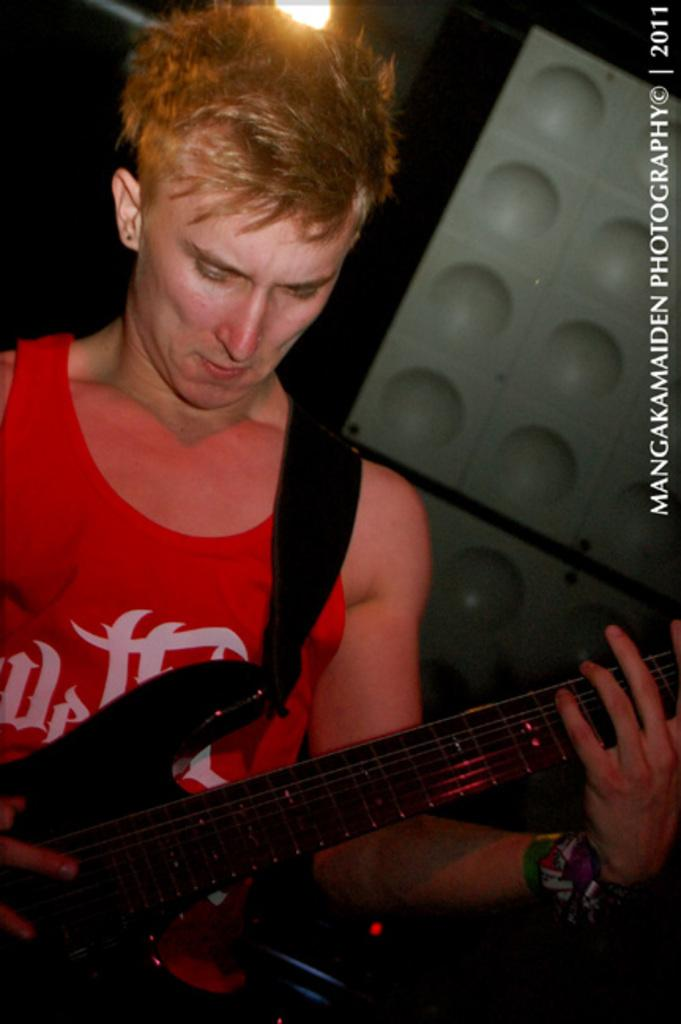What is the man in the image doing? The man is playing a guitar in the image. How is the man positioned in the image? The man is standing in the image. What is the man wearing in the image? The man is wearing a red sleeveless shirt in the image. What can be seen in the background of the image? There is a light visible in the image. What type of cork can be seen in the man's underwear in the image? There is no cork or underwear visible in the image; the man is wearing a red sleeveless shirt. Is the man playing the guitar in space in the image? There is no indication of space or any celestial bodies in the image; it appears to be an indoor setting. 